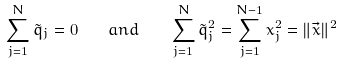Convert formula to latex. <formula><loc_0><loc_0><loc_500><loc_500>\sum _ { j = 1 } ^ { N } \tilde { q } _ { j } = 0 \quad a n d \quad \sum _ { j = 1 } ^ { N } \tilde { q } _ { j } ^ { 2 } = \sum _ { j = 1 } ^ { N - 1 } x _ { j } ^ { 2 } = \| \vec { x } \| ^ { 2 }</formula> 